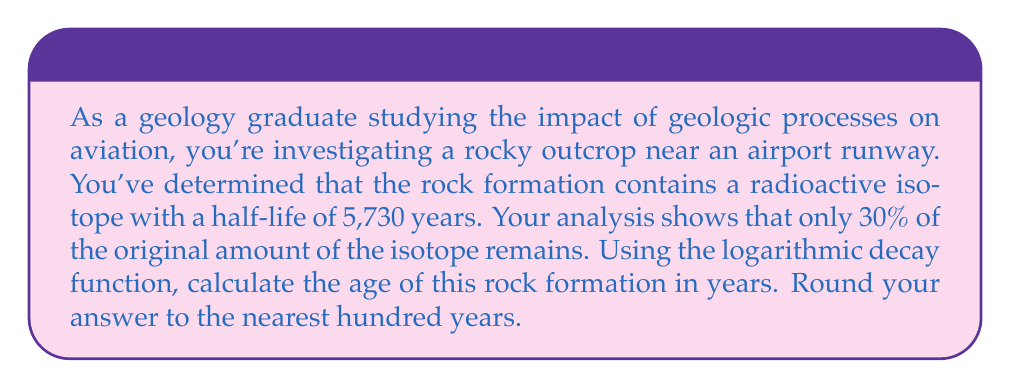Solve this math problem. To solve this problem, we'll use the radioactive decay formula and logarithms. Let's break it down step-by-step:

1) The general form of the radioactive decay formula is:

   $$N(t) = N_0 \cdot (1/2)^{t/t_{1/2}}$$

   Where:
   $N(t)$ is the amount remaining after time $t$
   $N_0$ is the initial amount
   $t$ is the time elapsed
   $t_{1/2}$ is the half-life

2) We know that 30% of the original amount remains, so $N(t)/N_0 = 0.30$. We can rewrite our equation:

   $$0.30 = (1/2)^{t/5730}$$

3) To solve for $t$, we need to use logarithms. Let's apply the natural log to both sides:

   $$\ln(0.30) = \ln((1/2)^{t/5730})$$

4) Using the logarithm property $\ln(a^b) = b\ln(a)$, we get:

   $$\ln(0.30) = (t/5730) \cdot \ln(1/2)$$

5) Solve for $t$:

   $$t = \frac{5730 \cdot \ln(0.30)}{\ln(1/2)}$$

6) Calculate:
   
   $$t = \frac{5730 \cdot (-1.2039)}{-0.6931} \approx 9943.8$$

7) Rounding to the nearest hundred years:

   $$t \approx 9,900 \text{ years}$$
Answer: The age of the rock formation is approximately 9,900 years. 